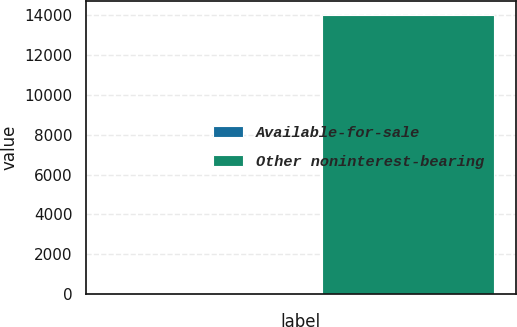Convert chart. <chart><loc_0><loc_0><loc_500><loc_500><bar_chart><fcel>Available-for-sale<fcel>Other noninterest-bearing<nl><fcel>30<fcel>14008<nl></chart> 